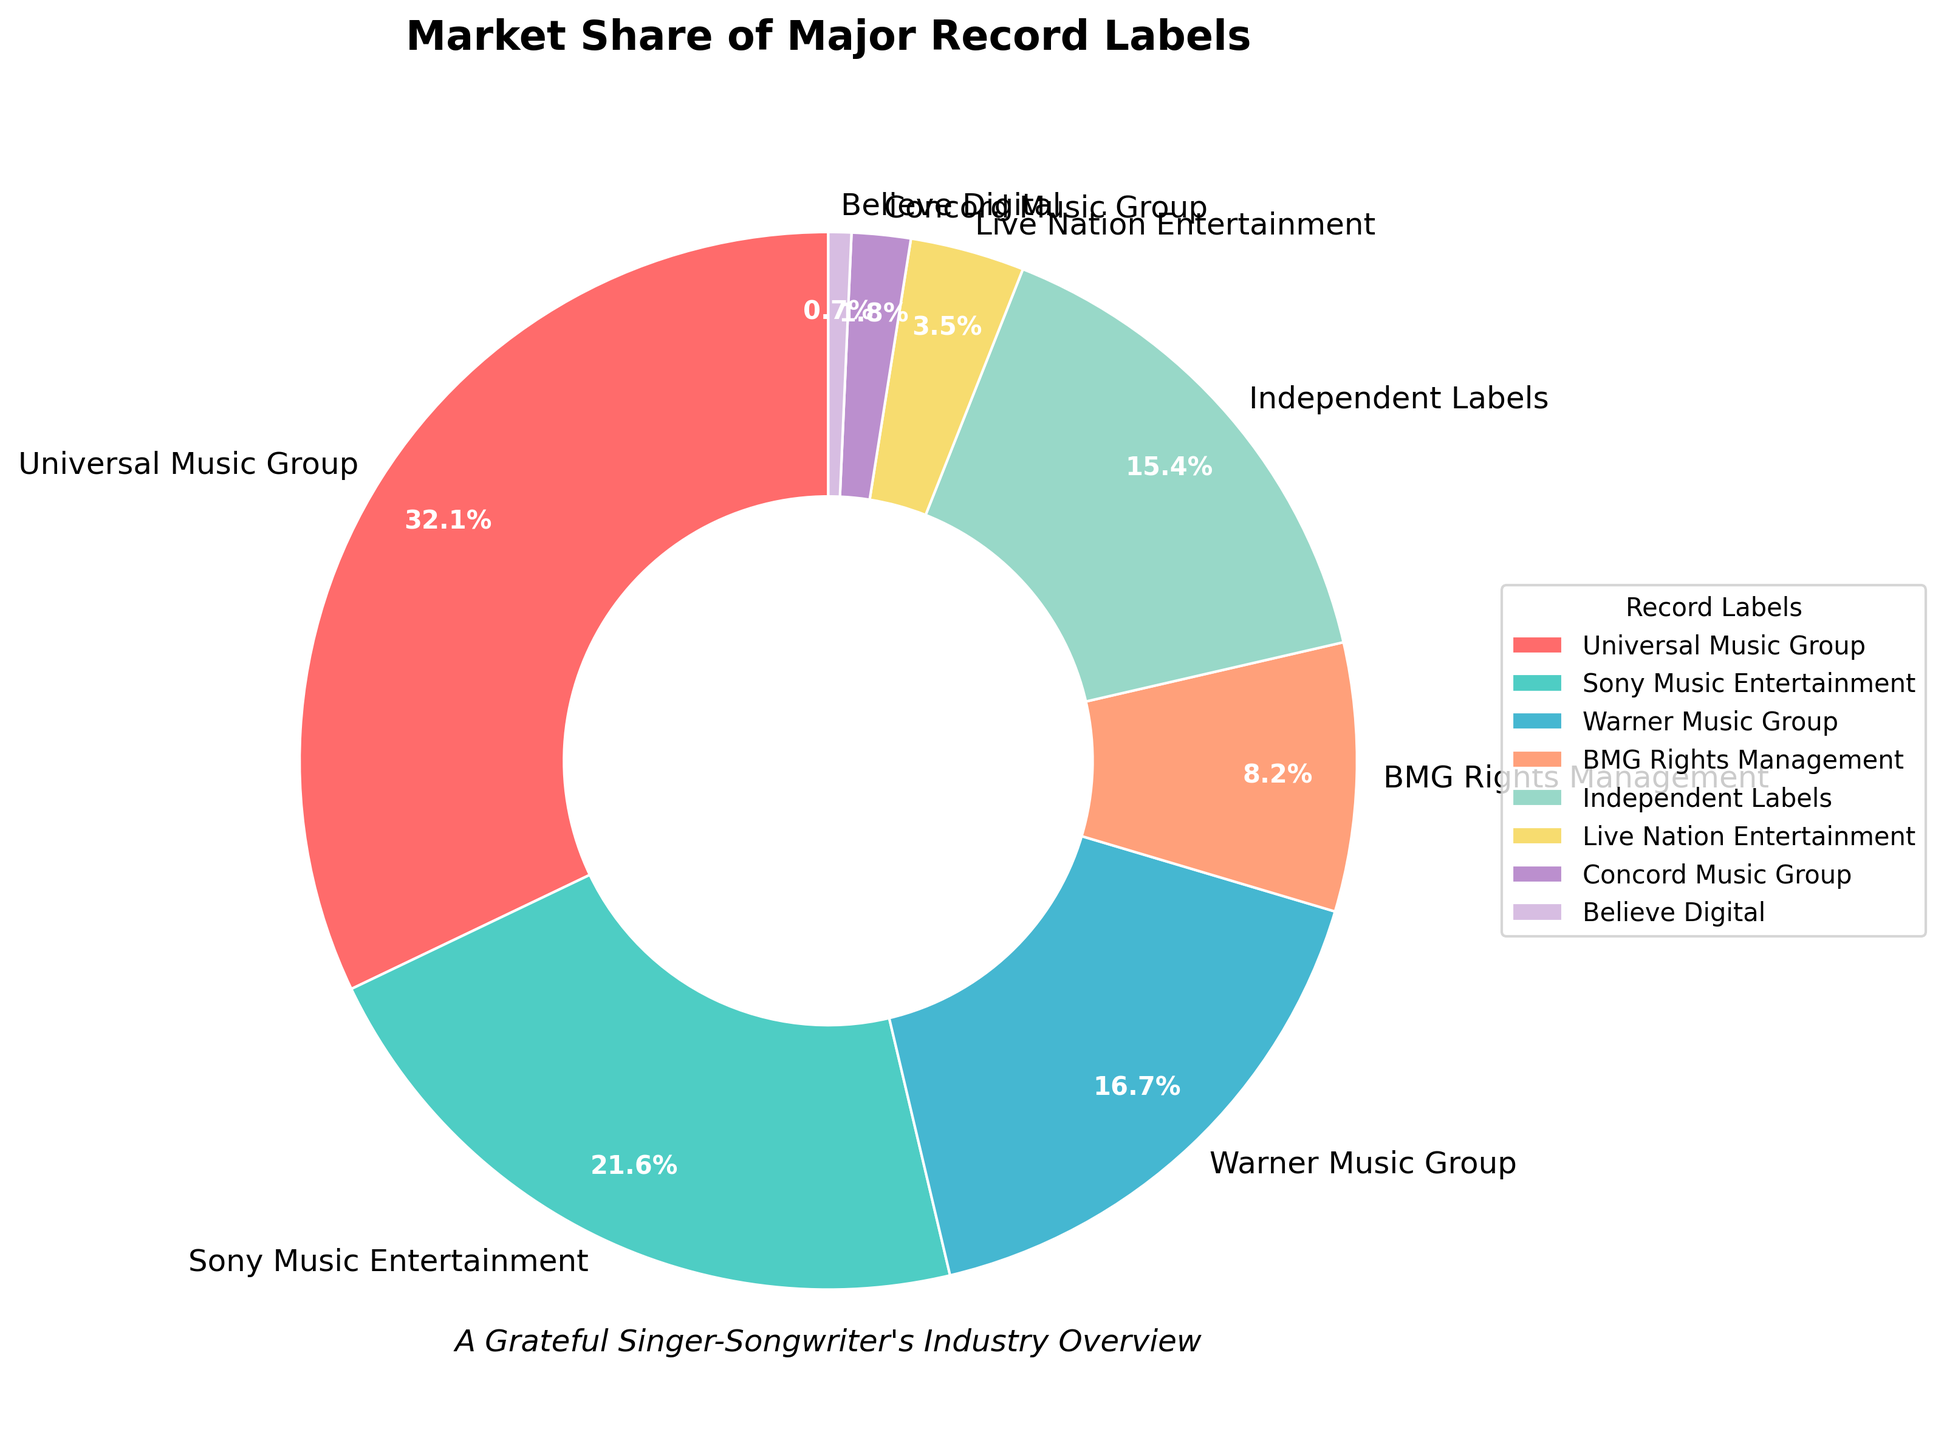What percentage of the market share do the top three labels combined hold? The top three labels are Universal Music Group (32.1%), Sony Music Entertainment (21.6%), and Warner Music Group (16.7%). Adding these together: 32.1 + 21.6 + 16.7 = 70.4
Answer: 70.4 Which label has the smallest market share, and what is it? By examining the labels and their corresponding market shares, the smallest market share is held by Believe Digital at 0.7%.
Answer: Believe Digital, 0.7% Is the market share of Independent Labels greater than the combined market share of BMG Rights Management and Concord Music Group? Independent Labels have a market share of 15.4%. BMG Rights Management and Concord Music Group have market shares of 8.2% and 1.8%, respectively. Their combined market share is 8.2 + 1.8 = 10. Therefore, yes, the market share of Independent Labels is greater.
Answer: Yes How much more market share does Universal Music Group have compared to Live Nation Entertainment? Universal Music Group has a market share of 32.1%, while Live Nation Entertainment has 3.5%. The difference is 32.1 - 3.5 = 28.6.
Answer: 28.6 Which labels hold more than 10% of the market share? Labels with more than 10% market share are Universal Music Group (32.1%), Sony Music Entertainment (21.6%), and Warner Music Group (16.7%).
Answer: Universal Music Group, Sony Music Entertainment, Warner Music Group What is the combined market share of the labels that have less than 5% of the market share each? Labels with less than 5% market share are Live Nation Entertainment (3.5%), Concord Music Group (1.8%), and Believe Digital (0.7%). Their combined market share is 3.5 + 1.8 + 0.7 = 6.0.
Answer: 6.0 What is the ratio of Sony Music Entertainment's market share to Warner Music Group's market share? Sony Music Entertainment has a market share of 21.6%, and Warner Music Group has 16.7%. The ratio is 21.6 / 16.7 = 1.29.
Answer: 1.29 What percentage of the market is controlled by labels other than the top three? The top three labels (Universal Music Group, Sony Music Entertainment, Warner Music Group) have a combined market share of 70.4%. Therefore, the market share of labels other than the top three is 100 - 70.4 = 29.6.
Answer: 29.6 How much less is the market share of BMG Rights Management compared to Sony Music Entertainment? BMG Rights Management has a market share of 8.2%, while Sony Music Entertainment has 21.6%. The difference is 21.6 - 8.2 = 13.4.
Answer: 13.4 What is the average market share of all the labels combined? The market shares in total (32.1 + 21.6 + 16.7 + 8.2 + 15.4 + 3.5 + 1.8 + 0.7) sum up to 100%. Since there are 8 labels, the average market share is 100 / 8 = 12.5
Answer: 12.5 